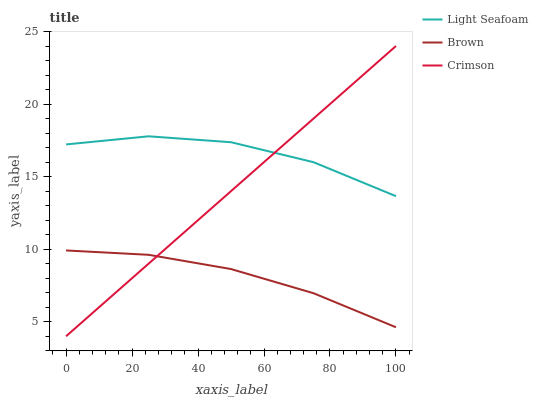Does Light Seafoam have the minimum area under the curve?
Answer yes or no. No. Does Brown have the maximum area under the curve?
Answer yes or no. No. Is Brown the smoothest?
Answer yes or no. No. Is Brown the roughest?
Answer yes or no. No. Does Brown have the lowest value?
Answer yes or no. No. Does Light Seafoam have the highest value?
Answer yes or no. No. Is Brown less than Light Seafoam?
Answer yes or no. Yes. Is Light Seafoam greater than Brown?
Answer yes or no. Yes. Does Brown intersect Light Seafoam?
Answer yes or no. No. 